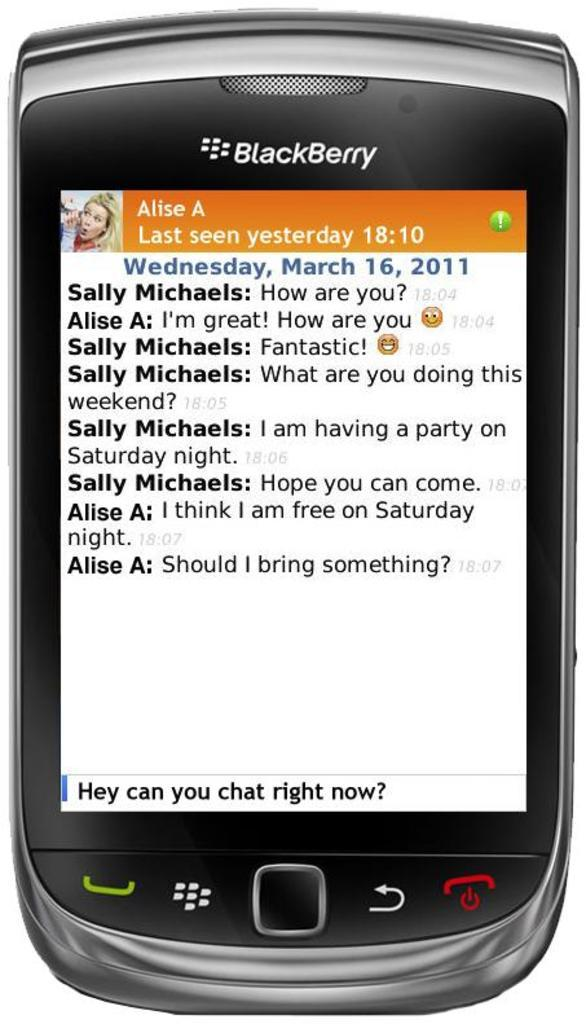<image>
Share a concise interpretation of the image provided. Messaging from Alise A, Last seen yesterday, is displayed on this BlackBerry. 